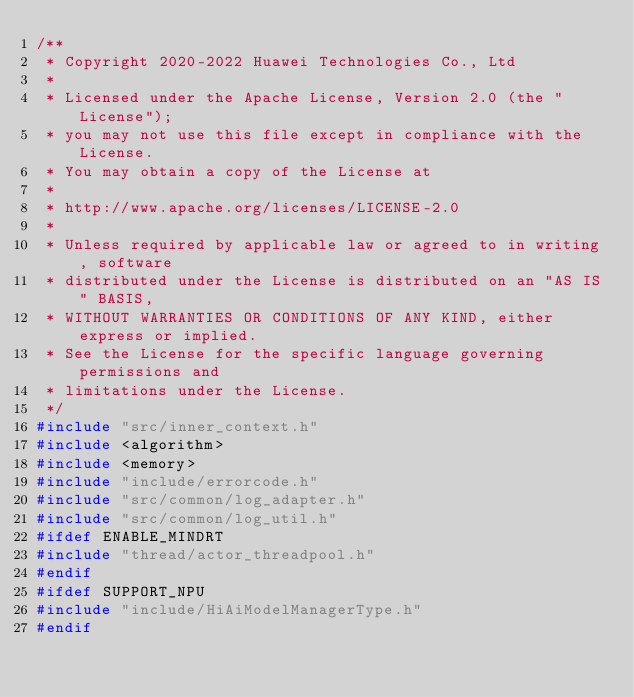Convert code to text. <code><loc_0><loc_0><loc_500><loc_500><_C++_>/**
 * Copyright 2020-2022 Huawei Technologies Co., Ltd
 *
 * Licensed under the Apache License, Version 2.0 (the "License");
 * you may not use this file except in compliance with the License.
 * You may obtain a copy of the License at
 *
 * http://www.apache.org/licenses/LICENSE-2.0
 *
 * Unless required by applicable law or agreed to in writing, software
 * distributed under the License is distributed on an "AS IS" BASIS,
 * WITHOUT WARRANTIES OR CONDITIONS OF ANY KIND, either express or implied.
 * See the License for the specific language governing permissions and
 * limitations under the License.
 */
#include "src/inner_context.h"
#include <algorithm>
#include <memory>
#include "include/errorcode.h"
#include "src/common/log_adapter.h"
#include "src/common/log_util.h"
#ifdef ENABLE_MINDRT
#include "thread/actor_threadpool.h"
#endif
#ifdef SUPPORT_NPU
#include "include/HiAiModelManagerType.h"
#endif</code> 